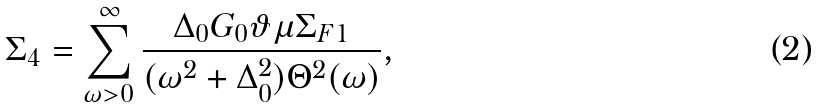<formula> <loc_0><loc_0><loc_500><loc_500>\Sigma _ { 4 } = \sum _ { \omega > 0 } ^ { \infty } \frac { \Delta _ { 0 } G _ { 0 } \vartheta \mu \Sigma _ { F 1 } } { ( \omega ^ { 2 } + \Delta _ { 0 } ^ { 2 } ) \Theta ^ { 2 } ( \omega ) } ,</formula> 